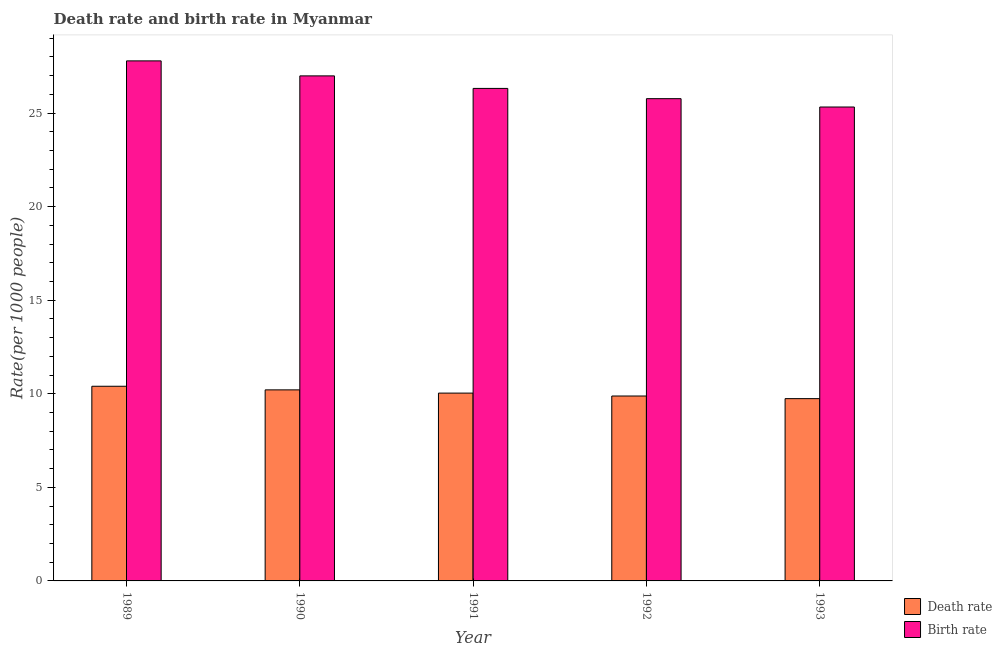Are the number of bars on each tick of the X-axis equal?
Your answer should be compact. Yes. How many bars are there on the 5th tick from the left?
Keep it short and to the point. 2. What is the label of the 2nd group of bars from the left?
Keep it short and to the point. 1990. What is the birth rate in 1991?
Your answer should be compact. 26.32. Across all years, what is the maximum death rate?
Give a very brief answer. 10.4. Across all years, what is the minimum birth rate?
Your answer should be very brief. 25.32. What is the total birth rate in the graph?
Your answer should be very brief. 132.18. What is the difference between the birth rate in 1989 and that in 1993?
Ensure brevity in your answer.  2.46. What is the difference between the death rate in 1990 and the birth rate in 1993?
Provide a succinct answer. 0.47. What is the average death rate per year?
Your response must be concise. 10.05. In the year 1993, what is the difference between the birth rate and death rate?
Offer a terse response. 0. In how many years, is the birth rate greater than 9?
Give a very brief answer. 5. What is the ratio of the death rate in 1991 to that in 1993?
Provide a succinct answer. 1.03. Is the birth rate in 1989 less than that in 1991?
Keep it short and to the point. No. Is the difference between the death rate in 1992 and 1993 greater than the difference between the birth rate in 1992 and 1993?
Make the answer very short. No. What is the difference between the highest and the second highest birth rate?
Keep it short and to the point. 0.8. What is the difference between the highest and the lowest birth rate?
Provide a short and direct response. 2.46. What does the 1st bar from the left in 1993 represents?
Give a very brief answer. Death rate. What does the 2nd bar from the right in 1993 represents?
Provide a succinct answer. Death rate. How many bars are there?
Your answer should be very brief. 10. What is the difference between two consecutive major ticks on the Y-axis?
Provide a short and direct response. 5. Where does the legend appear in the graph?
Offer a very short reply. Bottom right. How many legend labels are there?
Your answer should be compact. 2. How are the legend labels stacked?
Provide a short and direct response. Vertical. What is the title of the graph?
Offer a terse response. Death rate and birth rate in Myanmar. Does "ODA received" appear as one of the legend labels in the graph?
Offer a terse response. No. What is the label or title of the Y-axis?
Ensure brevity in your answer.  Rate(per 1000 people). What is the Rate(per 1000 people) of Death rate in 1989?
Your response must be concise. 10.4. What is the Rate(per 1000 people) of Birth rate in 1989?
Give a very brief answer. 27.79. What is the Rate(per 1000 people) of Death rate in 1990?
Your answer should be very brief. 10.21. What is the Rate(per 1000 people) in Birth rate in 1990?
Ensure brevity in your answer.  26.99. What is the Rate(per 1000 people) in Death rate in 1991?
Offer a very short reply. 10.04. What is the Rate(per 1000 people) in Birth rate in 1991?
Give a very brief answer. 26.32. What is the Rate(per 1000 people) of Death rate in 1992?
Offer a very short reply. 9.88. What is the Rate(per 1000 people) of Birth rate in 1992?
Your answer should be very brief. 25.77. What is the Rate(per 1000 people) in Death rate in 1993?
Offer a terse response. 9.74. What is the Rate(per 1000 people) in Birth rate in 1993?
Provide a succinct answer. 25.32. Across all years, what is the maximum Rate(per 1000 people) in Death rate?
Offer a very short reply. 10.4. Across all years, what is the maximum Rate(per 1000 people) in Birth rate?
Offer a very short reply. 27.79. Across all years, what is the minimum Rate(per 1000 people) in Death rate?
Keep it short and to the point. 9.74. Across all years, what is the minimum Rate(per 1000 people) of Birth rate?
Make the answer very short. 25.32. What is the total Rate(per 1000 people) of Death rate in the graph?
Your answer should be compact. 50.27. What is the total Rate(per 1000 people) of Birth rate in the graph?
Your response must be concise. 132.18. What is the difference between the Rate(per 1000 people) in Death rate in 1989 and that in 1990?
Your answer should be very brief. 0.19. What is the difference between the Rate(per 1000 people) in Birth rate in 1989 and that in 1990?
Offer a very short reply. 0.8. What is the difference between the Rate(per 1000 people) of Death rate in 1989 and that in 1991?
Make the answer very short. 0.37. What is the difference between the Rate(per 1000 people) of Birth rate in 1989 and that in 1991?
Make the answer very short. 1.47. What is the difference between the Rate(per 1000 people) of Death rate in 1989 and that in 1992?
Ensure brevity in your answer.  0.52. What is the difference between the Rate(per 1000 people) of Birth rate in 1989 and that in 1992?
Provide a short and direct response. 2.02. What is the difference between the Rate(per 1000 people) in Death rate in 1989 and that in 1993?
Offer a very short reply. 0.66. What is the difference between the Rate(per 1000 people) of Birth rate in 1989 and that in 1993?
Ensure brevity in your answer.  2.46. What is the difference between the Rate(per 1000 people) in Death rate in 1990 and that in 1991?
Keep it short and to the point. 0.17. What is the difference between the Rate(per 1000 people) in Birth rate in 1990 and that in 1991?
Ensure brevity in your answer.  0.67. What is the difference between the Rate(per 1000 people) of Death rate in 1990 and that in 1992?
Offer a very short reply. 0.33. What is the difference between the Rate(per 1000 people) in Birth rate in 1990 and that in 1992?
Keep it short and to the point. 1.22. What is the difference between the Rate(per 1000 people) in Death rate in 1990 and that in 1993?
Offer a very short reply. 0.47. What is the difference between the Rate(per 1000 people) of Birth rate in 1990 and that in 1993?
Make the answer very short. 1.66. What is the difference between the Rate(per 1000 people) of Death rate in 1991 and that in 1992?
Your answer should be compact. 0.15. What is the difference between the Rate(per 1000 people) in Birth rate in 1991 and that in 1992?
Ensure brevity in your answer.  0.55. What is the difference between the Rate(per 1000 people) of Death rate in 1991 and that in 1993?
Keep it short and to the point. 0.3. What is the difference between the Rate(per 1000 people) of Birth rate in 1991 and that in 1993?
Provide a short and direct response. 0.99. What is the difference between the Rate(per 1000 people) in Death rate in 1992 and that in 1993?
Your answer should be compact. 0.14. What is the difference between the Rate(per 1000 people) of Birth rate in 1992 and that in 1993?
Provide a short and direct response. 0.45. What is the difference between the Rate(per 1000 people) in Death rate in 1989 and the Rate(per 1000 people) in Birth rate in 1990?
Your response must be concise. -16.58. What is the difference between the Rate(per 1000 people) in Death rate in 1989 and the Rate(per 1000 people) in Birth rate in 1991?
Your answer should be very brief. -15.91. What is the difference between the Rate(per 1000 people) of Death rate in 1989 and the Rate(per 1000 people) of Birth rate in 1992?
Provide a succinct answer. -15.37. What is the difference between the Rate(per 1000 people) of Death rate in 1989 and the Rate(per 1000 people) of Birth rate in 1993?
Offer a very short reply. -14.92. What is the difference between the Rate(per 1000 people) in Death rate in 1990 and the Rate(per 1000 people) in Birth rate in 1991?
Your response must be concise. -16.11. What is the difference between the Rate(per 1000 people) in Death rate in 1990 and the Rate(per 1000 people) in Birth rate in 1992?
Ensure brevity in your answer.  -15.56. What is the difference between the Rate(per 1000 people) in Death rate in 1990 and the Rate(per 1000 people) in Birth rate in 1993?
Give a very brief answer. -15.11. What is the difference between the Rate(per 1000 people) of Death rate in 1991 and the Rate(per 1000 people) of Birth rate in 1992?
Give a very brief answer. -15.73. What is the difference between the Rate(per 1000 people) in Death rate in 1991 and the Rate(per 1000 people) in Birth rate in 1993?
Offer a terse response. -15.29. What is the difference between the Rate(per 1000 people) of Death rate in 1992 and the Rate(per 1000 people) of Birth rate in 1993?
Offer a very short reply. -15.44. What is the average Rate(per 1000 people) in Death rate per year?
Ensure brevity in your answer.  10.05. What is the average Rate(per 1000 people) in Birth rate per year?
Your answer should be compact. 26.44. In the year 1989, what is the difference between the Rate(per 1000 people) in Death rate and Rate(per 1000 people) in Birth rate?
Your answer should be very brief. -17.39. In the year 1990, what is the difference between the Rate(per 1000 people) of Death rate and Rate(per 1000 people) of Birth rate?
Your answer should be compact. -16.78. In the year 1991, what is the difference between the Rate(per 1000 people) of Death rate and Rate(per 1000 people) of Birth rate?
Keep it short and to the point. -16.28. In the year 1992, what is the difference between the Rate(per 1000 people) in Death rate and Rate(per 1000 people) in Birth rate?
Make the answer very short. -15.89. In the year 1993, what is the difference between the Rate(per 1000 people) of Death rate and Rate(per 1000 people) of Birth rate?
Keep it short and to the point. -15.58. What is the ratio of the Rate(per 1000 people) in Death rate in 1989 to that in 1990?
Provide a succinct answer. 1.02. What is the ratio of the Rate(per 1000 people) in Birth rate in 1989 to that in 1990?
Your answer should be very brief. 1.03. What is the ratio of the Rate(per 1000 people) of Death rate in 1989 to that in 1991?
Your answer should be very brief. 1.04. What is the ratio of the Rate(per 1000 people) in Birth rate in 1989 to that in 1991?
Offer a very short reply. 1.06. What is the ratio of the Rate(per 1000 people) of Death rate in 1989 to that in 1992?
Your answer should be compact. 1.05. What is the ratio of the Rate(per 1000 people) of Birth rate in 1989 to that in 1992?
Ensure brevity in your answer.  1.08. What is the ratio of the Rate(per 1000 people) of Death rate in 1989 to that in 1993?
Ensure brevity in your answer.  1.07. What is the ratio of the Rate(per 1000 people) in Birth rate in 1989 to that in 1993?
Your answer should be compact. 1.1. What is the ratio of the Rate(per 1000 people) in Death rate in 1990 to that in 1991?
Ensure brevity in your answer.  1.02. What is the ratio of the Rate(per 1000 people) of Birth rate in 1990 to that in 1991?
Give a very brief answer. 1.03. What is the ratio of the Rate(per 1000 people) of Death rate in 1990 to that in 1992?
Offer a very short reply. 1.03. What is the ratio of the Rate(per 1000 people) of Birth rate in 1990 to that in 1992?
Make the answer very short. 1.05. What is the ratio of the Rate(per 1000 people) of Death rate in 1990 to that in 1993?
Make the answer very short. 1.05. What is the ratio of the Rate(per 1000 people) in Birth rate in 1990 to that in 1993?
Provide a short and direct response. 1.07. What is the ratio of the Rate(per 1000 people) of Death rate in 1991 to that in 1992?
Your response must be concise. 1.02. What is the ratio of the Rate(per 1000 people) of Birth rate in 1991 to that in 1992?
Ensure brevity in your answer.  1.02. What is the ratio of the Rate(per 1000 people) of Death rate in 1991 to that in 1993?
Provide a short and direct response. 1.03. What is the ratio of the Rate(per 1000 people) in Birth rate in 1991 to that in 1993?
Provide a short and direct response. 1.04. What is the ratio of the Rate(per 1000 people) in Death rate in 1992 to that in 1993?
Your answer should be very brief. 1.01. What is the ratio of the Rate(per 1000 people) of Birth rate in 1992 to that in 1993?
Offer a very short reply. 1.02. What is the difference between the highest and the second highest Rate(per 1000 people) of Death rate?
Give a very brief answer. 0.19. What is the difference between the highest and the second highest Rate(per 1000 people) in Birth rate?
Make the answer very short. 0.8. What is the difference between the highest and the lowest Rate(per 1000 people) of Death rate?
Ensure brevity in your answer.  0.66. What is the difference between the highest and the lowest Rate(per 1000 people) in Birth rate?
Offer a terse response. 2.46. 